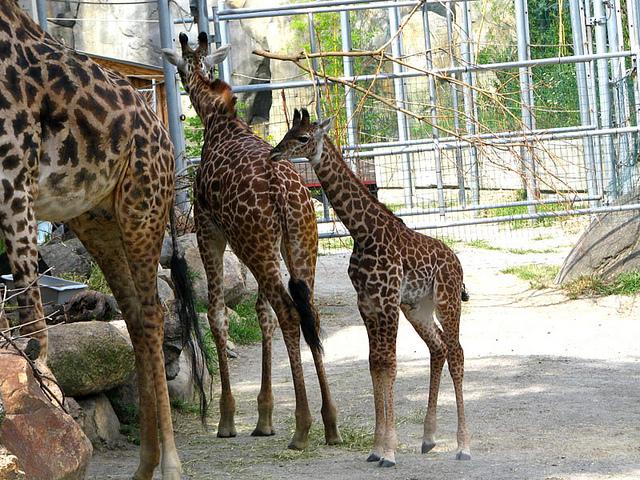Who feeds the animals?
Answer briefly. Zookeeper. Are the giraffes in the wild or are they in a zoo?
Keep it brief. Zoo. How many baby giraffes are there?
Concise answer only. 1. 